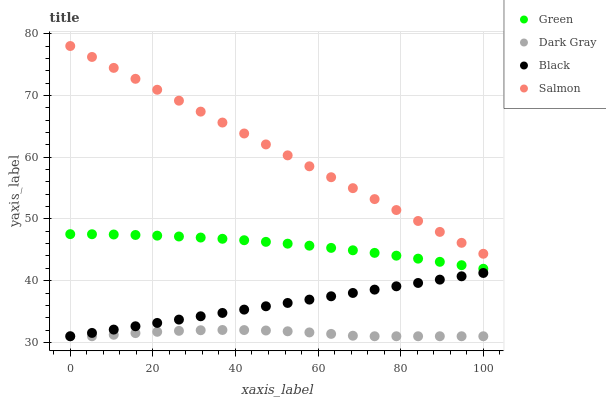Does Dark Gray have the minimum area under the curve?
Answer yes or no. Yes. Does Salmon have the maximum area under the curve?
Answer yes or no. Yes. Does Black have the minimum area under the curve?
Answer yes or no. No. Does Black have the maximum area under the curve?
Answer yes or no. No. Is Black the smoothest?
Answer yes or no. Yes. Is Dark Gray the roughest?
Answer yes or no. Yes. Is Green the smoothest?
Answer yes or no. No. Is Green the roughest?
Answer yes or no. No. Does Dark Gray have the lowest value?
Answer yes or no. Yes. Does Green have the lowest value?
Answer yes or no. No. Does Salmon have the highest value?
Answer yes or no. Yes. Does Black have the highest value?
Answer yes or no. No. Is Green less than Salmon?
Answer yes or no. Yes. Is Salmon greater than Green?
Answer yes or no. Yes. Does Black intersect Dark Gray?
Answer yes or no. Yes. Is Black less than Dark Gray?
Answer yes or no. No. Is Black greater than Dark Gray?
Answer yes or no. No. Does Green intersect Salmon?
Answer yes or no. No. 